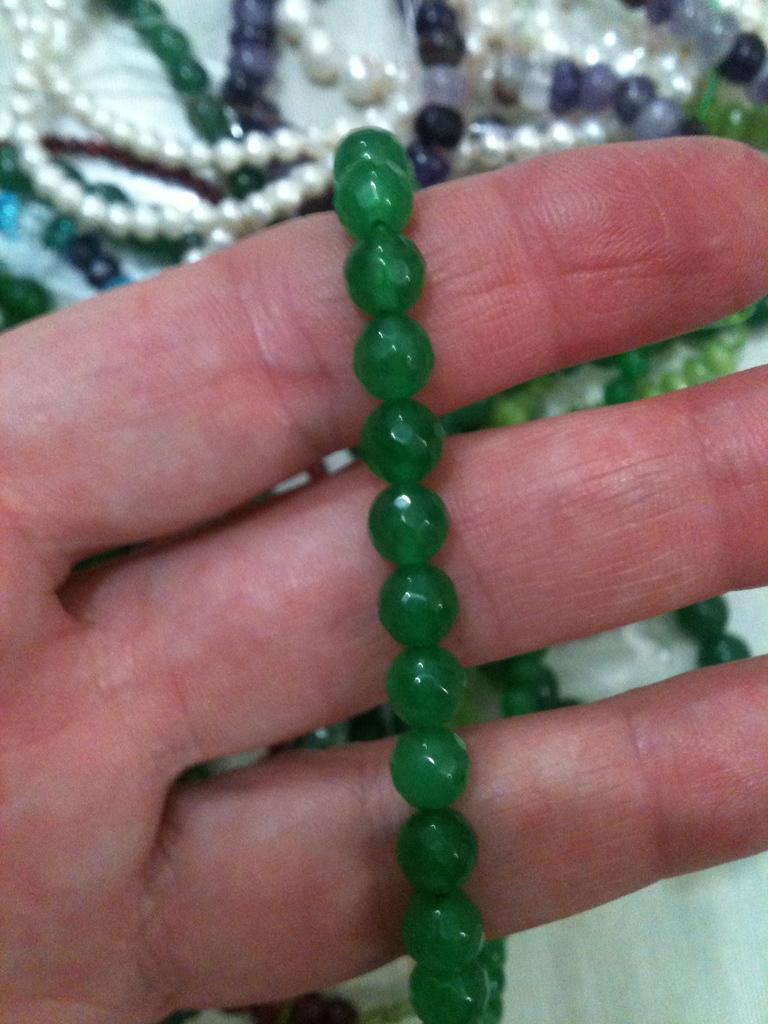What is the person's hand holding in the image? The person's hand is holding a green color beads chain in the image. Can you describe the background of the image? The background of the image is slightly blurred. What else can be seen related to beads chains in the image? There are more beads chains visible in the background of the image. What type of harmony is being played on the edge of the beads chain in the image? There is no indication of any musical harmony or instrument in the image; it features a person's hand holding a green color beads chain with a blurred background. 